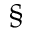<formula> <loc_0><loc_0><loc_500><loc_500>^ { \S }</formula> 